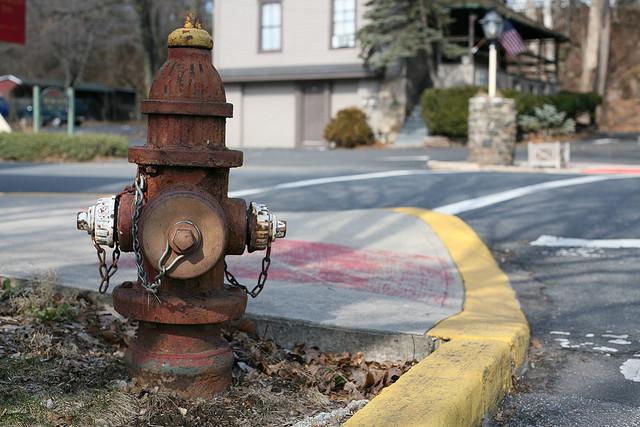Is the hydrant working?
Answer briefly. No. What kind of flag is there?
Quick response, please. American. Is this a residential street?
Give a very brief answer. Yes. 